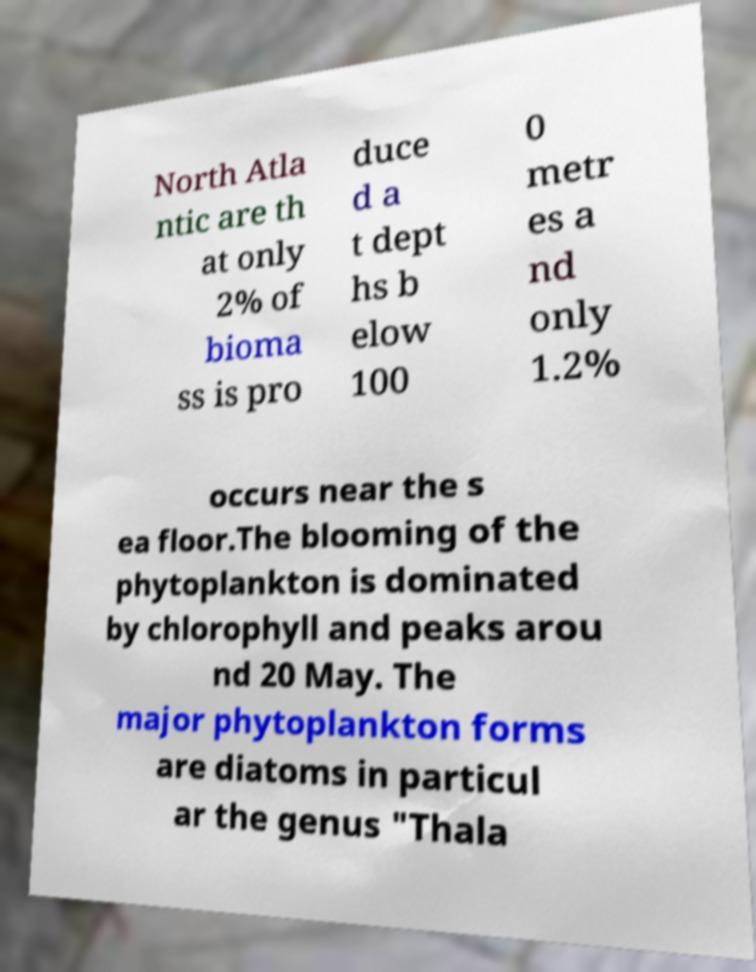Please read and relay the text visible in this image. What does it say? North Atla ntic are th at only 2% of bioma ss is pro duce d a t dept hs b elow 100 0 metr es a nd only 1.2% occurs near the s ea floor.The blooming of the phytoplankton is dominated by chlorophyll and peaks arou nd 20 May. The major phytoplankton forms are diatoms in particul ar the genus "Thala 